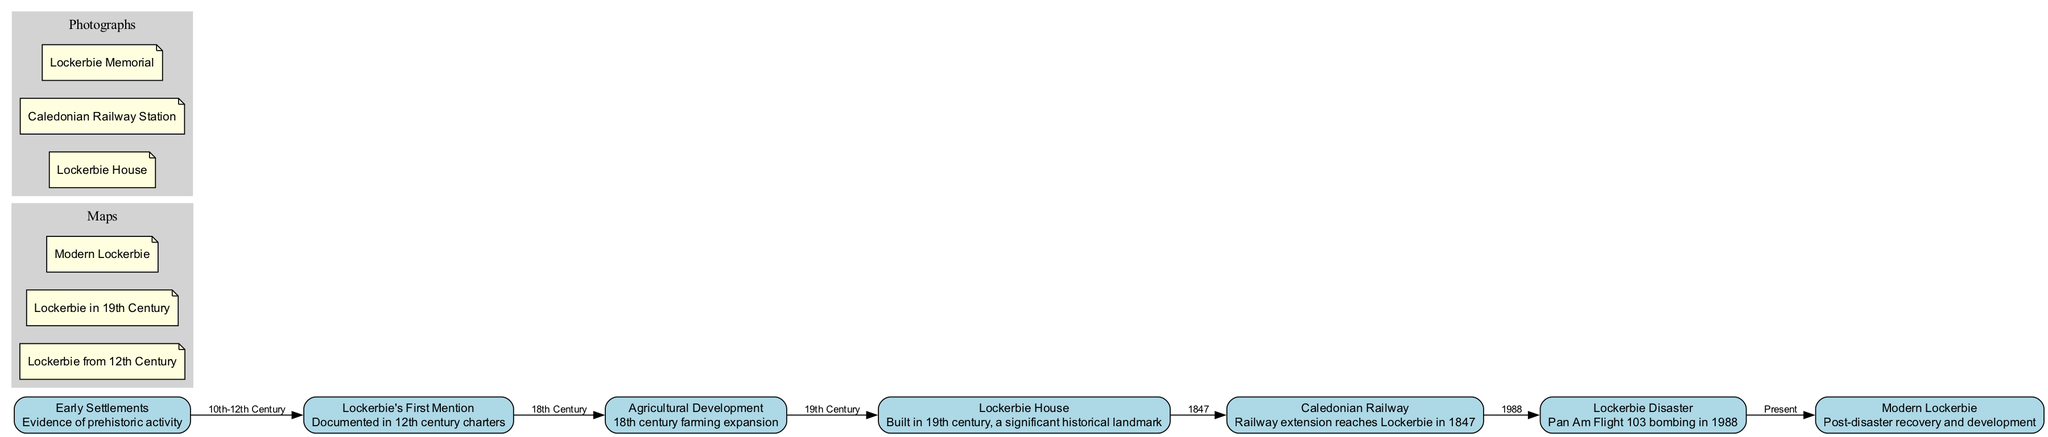What is the earliest historical event represented in the diagram? The diagram lists “Early Settlements” as the first node, indicating evidence of prehistoric activity as the earliest historical event.
Answer: Early Settlements In which century is Lockerbie's first mention documented? The edge connecting "Lockerbie's First Mention" node indicates that this event is documented in the 12th century.
Answer: 12th century What significant development occurred in the 18th century in Lockerbie? The edge from "Lockerbie's First Mention" to "Agricultural Development" indicates the event of farming expansion in the 18th century is significant.
Answer: Agricultural Development Which landmark was built in the 19th century? The node "Lockerbie House" specifies that this significant historical landmark was built in the 19th century.
Answer: Lockerbie House What event directly preceded the Lockerbie Disaster in the timeline? The edge from "Caledonian Railway" to "Lockerbie Disaster" indicates that the railway extension reaching Lockerbie occurred in 1847, which is directly before the bombing event in 1988.
Answer: Caledonian Railway How many photographs are included in the diagram? The section for photographs contains three entries, showing that there are three photographs included in the diagram.
Answer: 3 What kind of railway was extended to Lockerbie? The description associated with the node "Caledonian Railway" specifies that it was a railway that reached Lockerbie in 1847.
Answer: Caledonian Railway What is the major focus of modern Lockerbie as shown in the diagram? The node "Modern Lockerbie" highlights post-disaster recovery and development. This information indicates the current focus of Lockerbie's historical progress.
Answer: Post-disaster recovery Which historical event connects "Lockerbie House" and "Caledonian Railway"? The edge indicates that "Lockerbie House" leads to "Caledonian Railway", showing that the connection existed since their respective developments in the 19th century.
Answer: 19th century 